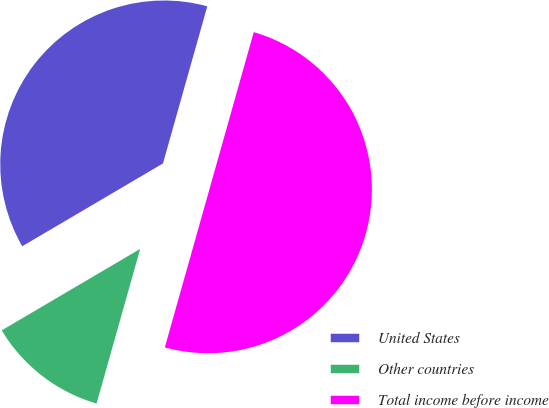Convert chart. <chart><loc_0><loc_0><loc_500><loc_500><pie_chart><fcel>United States<fcel>Other countries<fcel>Total income before income<nl><fcel>37.84%<fcel>12.16%<fcel>50.0%<nl></chart> 